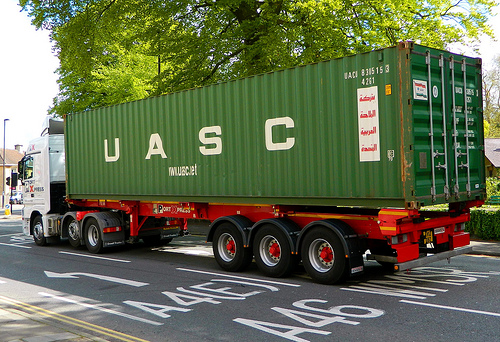Realistically speaking, could this container be repurposed? If so, how? Realistically, the container in the image can be repurposed in numerous ways. It can be converted into a storage unit for farming equipment, a mobile office space, or even a tiny home or an outdoor camp office. Containers are often repurposed for modular construction, creating affordable and sustainable housing solutions. What about using the container for disaster relief? For disaster relief, the container could play a vital role. It could be swiftly converted into mobile clinics, shelters, or emergency supply storage. Its robust structure makes it ideal for protecting essential resources and providing safe spaces in disaster zones. Additionally, outfitting the container with solar panels and water purification systems can further enhance its utility in providing immediate and sustainable relief efforts. 